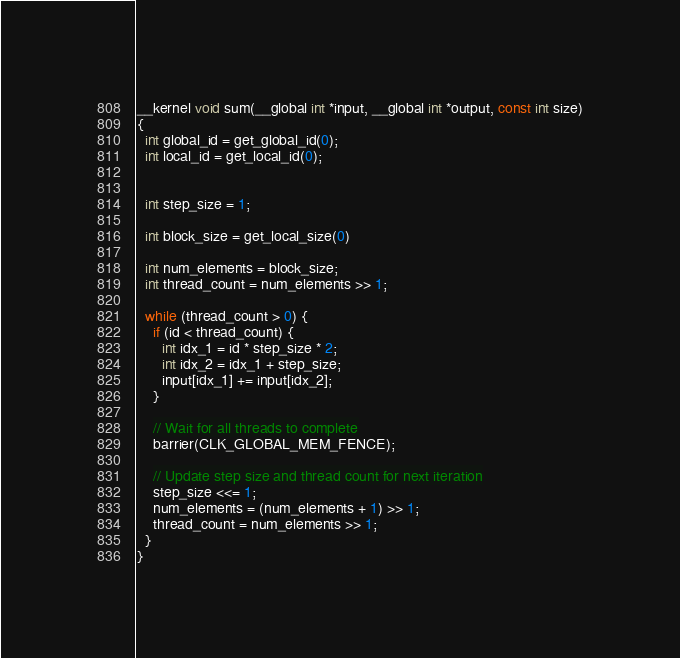<code> <loc_0><loc_0><loc_500><loc_500><_Cuda_>__kernel void sum(__global int *input, __global int *output, const int size)
{
  int global_id = get_global_id(0);
  int local_id = get_local_id(0);

  
  int step_size = 1;

  int block_size = get_local_size(0)

  int num_elements = block_size;
  int thread_count = num_elements >> 1;

  while (thread_count > 0) {
    if (id < thread_count) {
      int idx_1 = id * step_size * 2;
      int idx_2 = idx_1 + step_size;
      input[idx_1] += input[idx_2];
    }

    // Wait for all threads to complete
    barrier(CLK_GLOBAL_MEM_FENCE);

    // Update step size and thread count for next iteration
    step_size <<= 1;
    num_elements = (num_elements + 1) >> 1;
    thread_count = num_elements >> 1;
  }
}</code> 